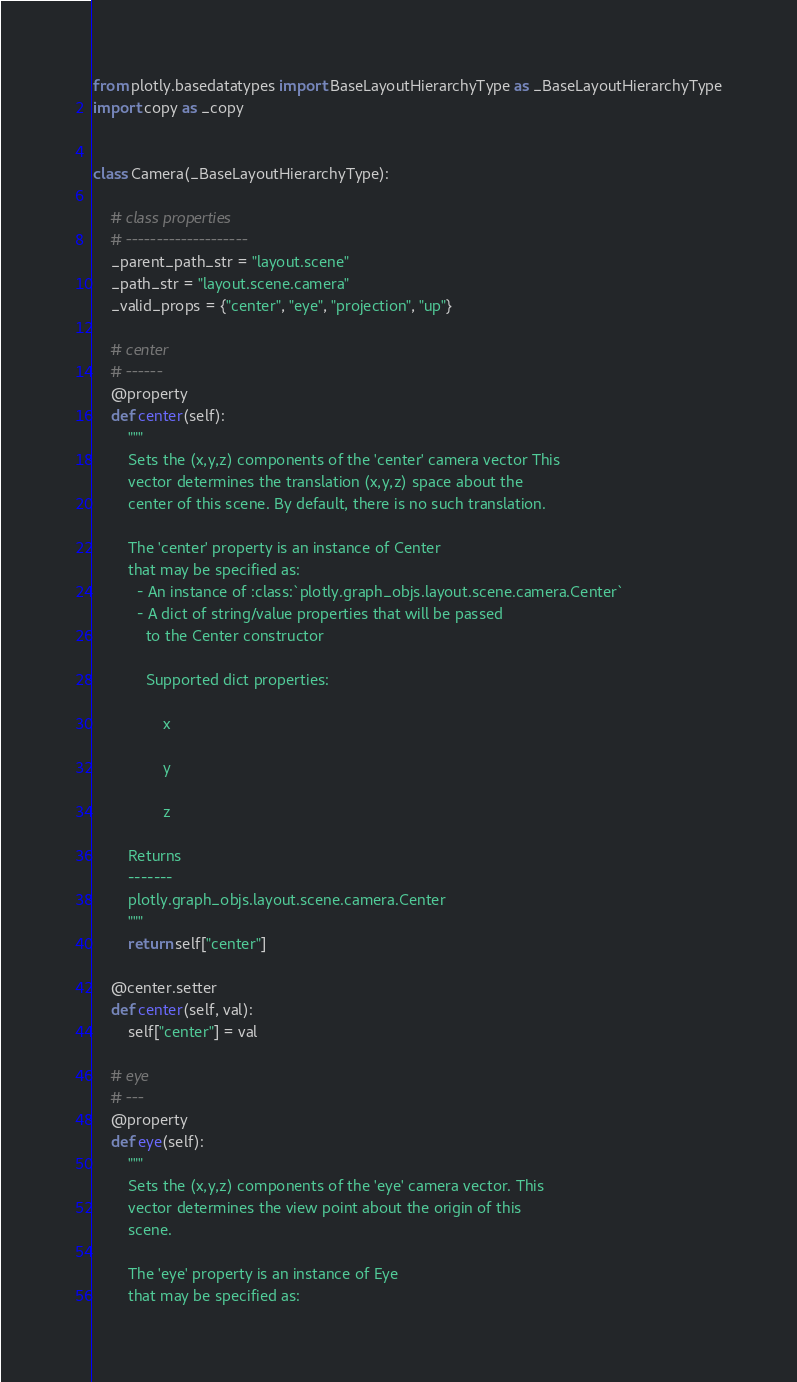Convert code to text. <code><loc_0><loc_0><loc_500><loc_500><_Python_>from plotly.basedatatypes import BaseLayoutHierarchyType as _BaseLayoutHierarchyType
import copy as _copy


class Camera(_BaseLayoutHierarchyType):

    # class properties
    # --------------------
    _parent_path_str = "layout.scene"
    _path_str = "layout.scene.camera"
    _valid_props = {"center", "eye", "projection", "up"}

    # center
    # ------
    @property
    def center(self):
        """
        Sets the (x,y,z) components of the 'center' camera vector This
        vector determines the translation (x,y,z) space about the
        center of this scene. By default, there is no such translation.

        The 'center' property is an instance of Center
        that may be specified as:
          - An instance of :class:`plotly.graph_objs.layout.scene.camera.Center`
          - A dict of string/value properties that will be passed
            to the Center constructor

            Supported dict properties:

                x

                y

                z

        Returns
        -------
        plotly.graph_objs.layout.scene.camera.Center
        """
        return self["center"]

    @center.setter
    def center(self, val):
        self["center"] = val

    # eye
    # ---
    @property
    def eye(self):
        """
        Sets the (x,y,z) components of the 'eye' camera vector. This
        vector determines the view point about the origin of this
        scene.

        The 'eye' property is an instance of Eye
        that may be specified as:</code> 